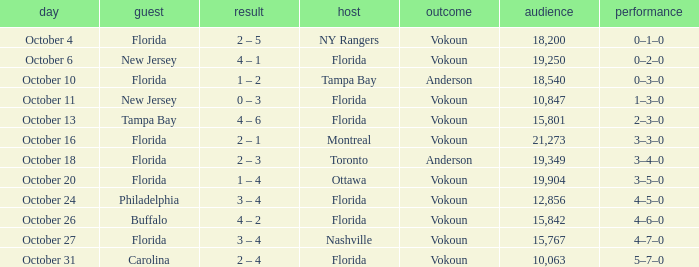What was the score on October 31? 2 – 4. 